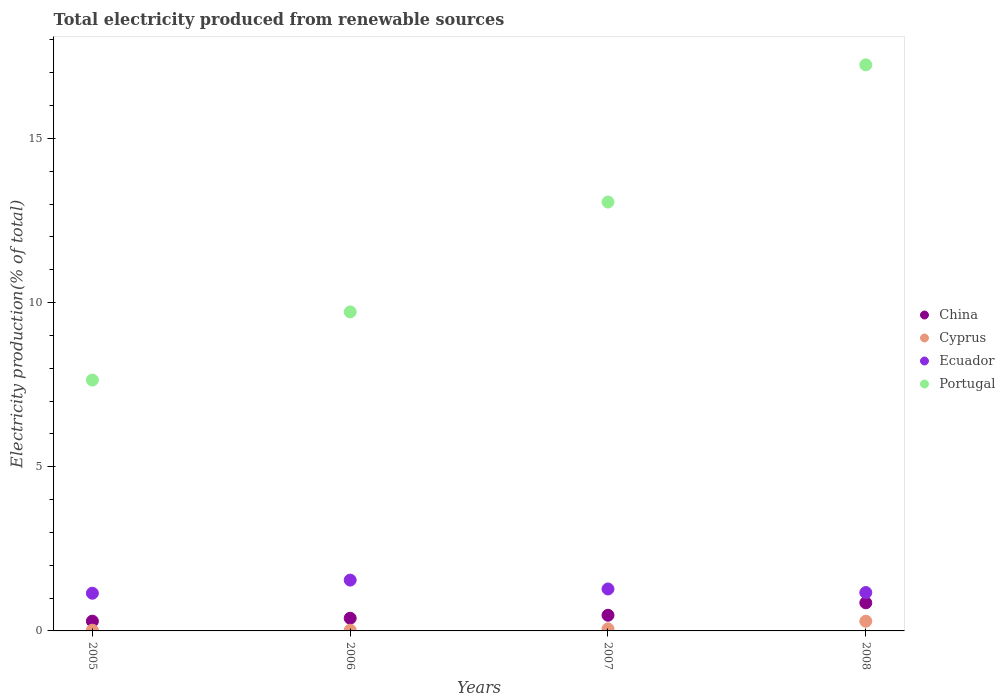How many different coloured dotlines are there?
Offer a terse response. 4. What is the total electricity produced in Cyprus in 2008?
Your response must be concise. 0.3. Across all years, what is the maximum total electricity produced in China?
Provide a succinct answer. 0.86. Across all years, what is the minimum total electricity produced in Ecuador?
Your response must be concise. 1.15. In which year was the total electricity produced in Portugal maximum?
Ensure brevity in your answer.  2008. What is the total total electricity produced in Ecuador in the graph?
Keep it short and to the point. 5.14. What is the difference between the total electricity produced in China in 2006 and that in 2008?
Keep it short and to the point. -0.47. What is the difference between the total electricity produced in China in 2006 and the total electricity produced in Cyprus in 2005?
Keep it short and to the point. 0.36. What is the average total electricity produced in Cyprus per year?
Provide a succinct answer. 0.1. In the year 2008, what is the difference between the total electricity produced in Ecuador and total electricity produced in Cyprus?
Provide a succinct answer. 0.87. In how many years, is the total electricity produced in China greater than 4 %?
Provide a short and direct response. 0. What is the ratio of the total electricity produced in Portugal in 2006 to that in 2008?
Offer a very short reply. 0.56. Is the total electricity produced in Ecuador in 2007 less than that in 2008?
Give a very brief answer. No. What is the difference between the highest and the second highest total electricity produced in Ecuador?
Ensure brevity in your answer.  0.27. What is the difference between the highest and the lowest total electricity produced in China?
Your answer should be compact. 0.56. In how many years, is the total electricity produced in Ecuador greater than the average total electricity produced in Ecuador taken over all years?
Make the answer very short. 1. Is the sum of the total electricity produced in China in 2005 and 2008 greater than the maximum total electricity produced in Ecuador across all years?
Your answer should be very brief. No. Is it the case that in every year, the sum of the total electricity produced in Portugal and total electricity produced in China  is greater than the total electricity produced in Ecuador?
Keep it short and to the point. Yes. Does the total electricity produced in Portugal monotonically increase over the years?
Your answer should be compact. Yes. Is the total electricity produced in Cyprus strictly less than the total electricity produced in Ecuador over the years?
Offer a terse response. Yes. How many years are there in the graph?
Provide a succinct answer. 4. Are the values on the major ticks of Y-axis written in scientific E-notation?
Your answer should be compact. No. How many legend labels are there?
Give a very brief answer. 4. How are the legend labels stacked?
Your response must be concise. Vertical. What is the title of the graph?
Provide a short and direct response. Total electricity produced from renewable sources. Does "Belgium" appear as one of the legend labels in the graph?
Keep it short and to the point. No. What is the label or title of the X-axis?
Your answer should be compact. Years. What is the Electricity production(% of total) of China in 2005?
Give a very brief answer. 0.3. What is the Electricity production(% of total) in Cyprus in 2005?
Your answer should be compact. 0.02. What is the Electricity production(% of total) in Ecuador in 2005?
Offer a very short reply. 1.15. What is the Electricity production(% of total) in Portugal in 2005?
Ensure brevity in your answer.  7.64. What is the Electricity production(% of total) in China in 2006?
Your response must be concise. 0.39. What is the Electricity production(% of total) of Cyprus in 2006?
Keep it short and to the point. 0.02. What is the Electricity production(% of total) in Ecuador in 2006?
Offer a very short reply. 1.55. What is the Electricity production(% of total) of Portugal in 2006?
Offer a terse response. 9.72. What is the Electricity production(% of total) in China in 2007?
Your answer should be compact. 0.48. What is the Electricity production(% of total) in Cyprus in 2007?
Keep it short and to the point. 0.06. What is the Electricity production(% of total) of Ecuador in 2007?
Your answer should be compact. 1.28. What is the Electricity production(% of total) in Portugal in 2007?
Make the answer very short. 13.06. What is the Electricity production(% of total) in China in 2008?
Make the answer very short. 0.86. What is the Electricity production(% of total) in Cyprus in 2008?
Your answer should be very brief. 0.3. What is the Electricity production(% of total) of Ecuador in 2008?
Your answer should be compact. 1.17. What is the Electricity production(% of total) of Portugal in 2008?
Your answer should be very brief. 17.24. Across all years, what is the maximum Electricity production(% of total) in China?
Your answer should be very brief. 0.86. Across all years, what is the maximum Electricity production(% of total) of Cyprus?
Give a very brief answer. 0.3. Across all years, what is the maximum Electricity production(% of total) in Ecuador?
Your answer should be compact. 1.55. Across all years, what is the maximum Electricity production(% of total) in Portugal?
Your response must be concise. 17.24. Across all years, what is the minimum Electricity production(% of total) of China?
Provide a short and direct response. 0.3. Across all years, what is the minimum Electricity production(% of total) in Cyprus?
Offer a terse response. 0.02. Across all years, what is the minimum Electricity production(% of total) in Ecuador?
Ensure brevity in your answer.  1.15. Across all years, what is the minimum Electricity production(% of total) in Portugal?
Provide a short and direct response. 7.64. What is the total Electricity production(% of total) in China in the graph?
Keep it short and to the point. 2.02. What is the total Electricity production(% of total) of Cyprus in the graph?
Offer a very short reply. 0.4. What is the total Electricity production(% of total) of Ecuador in the graph?
Your answer should be very brief. 5.14. What is the total Electricity production(% of total) in Portugal in the graph?
Your answer should be very brief. 47.66. What is the difference between the Electricity production(% of total) of China in 2005 and that in 2006?
Make the answer very short. -0.09. What is the difference between the Electricity production(% of total) in Cyprus in 2005 and that in 2006?
Ensure brevity in your answer.  0. What is the difference between the Electricity production(% of total) of Ecuador in 2005 and that in 2006?
Your answer should be very brief. -0.4. What is the difference between the Electricity production(% of total) in Portugal in 2005 and that in 2006?
Provide a short and direct response. -2.08. What is the difference between the Electricity production(% of total) of China in 2005 and that in 2007?
Provide a short and direct response. -0.18. What is the difference between the Electricity production(% of total) of Cyprus in 2005 and that in 2007?
Offer a terse response. -0.04. What is the difference between the Electricity production(% of total) of Ecuador in 2005 and that in 2007?
Make the answer very short. -0.13. What is the difference between the Electricity production(% of total) in Portugal in 2005 and that in 2007?
Your answer should be compact. -5.42. What is the difference between the Electricity production(% of total) of China in 2005 and that in 2008?
Offer a terse response. -0.56. What is the difference between the Electricity production(% of total) in Cyprus in 2005 and that in 2008?
Your answer should be compact. -0.27. What is the difference between the Electricity production(% of total) of Ecuador in 2005 and that in 2008?
Make the answer very short. -0.02. What is the difference between the Electricity production(% of total) of Portugal in 2005 and that in 2008?
Offer a terse response. -9.6. What is the difference between the Electricity production(% of total) in China in 2006 and that in 2007?
Keep it short and to the point. -0.09. What is the difference between the Electricity production(% of total) of Cyprus in 2006 and that in 2007?
Your answer should be very brief. -0.04. What is the difference between the Electricity production(% of total) of Ecuador in 2006 and that in 2007?
Your answer should be very brief. 0.27. What is the difference between the Electricity production(% of total) of Portugal in 2006 and that in 2007?
Offer a terse response. -3.35. What is the difference between the Electricity production(% of total) in China in 2006 and that in 2008?
Keep it short and to the point. -0.47. What is the difference between the Electricity production(% of total) in Cyprus in 2006 and that in 2008?
Offer a terse response. -0.27. What is the difference between the Electricity production(% of total) in Ecuador in 2006 and that in 2008?
Your response must be concise. 0.38. What is the difference between the Electricity production(% of total) of Portugal in 2006 and that in 2008?
Give a very brief answer. -7.53. What is the difference between the Electricity production(% of total) in China in 2007 and that in 2008?
Provide a short and direct response. -0.38. What is the difference between the Electricity production(% of total) in Cyprus in 2007 and that in 2008?
Your answer should be very brief. -0.23. What is the difference between the Electricity production(% of total) in Ecuador in 2007 and that in 2008?
Give a very brief answer. 0.11. What is the difference between the Electricity production(% of total) of Portugal in 2007 and that in 2008?
Your answer should be very brief. -4.18. What is the difference between the Electricity production(% of total) of China in 2005 and the Electricity production(% of total) of Cyprus in 2006?
Your answer should be compact. 0.28. What is the difference between the Electricity production(% of total) of China in 2005 and the Electricity production(% of total) of Ecuador in 2006?
Provide a short and direct response. -1.25. What is the difference between the Electricity production(% of total) of China in 2005 and the Electricity production(% of total) of Portugal in 2006?
Ensure brevity in your answer.  -9.42. What is the difference between the Electricity production(% of total) in Cyprus in 2005 and the Electricity production(% of total) in Ecuador in 2006?
Make the answer very short. -1.53. What is the difference between the Electricity production(% of total) in Cyprus in 2005 and the Electricity production(% of total) in Portugal in 2006?
Give a very brief answer. -9.69. What is the difference between the Electricity production(% of total) in Ecuador in 2005 and the Electricity production(% of total) in Portugal in 2006?
Provide a short and direct response. -8.57. What is the difference between the Electricity production(% of total) in China in 2005 and the Electricity production(% of total) in Cyprus in 2007?
Ensure brevity in your answer.  0.24. What is the difference between the Electricity production(% of total) in China in 2005 and the Electricity production(% of total) in Ecuador in 2007?
Your answer should be very brief. -0.98. What is the difference between the Electricity production(% of total) of China in 2005 and the Electricity production(% of total) of Portugal in 2007?
Make the answer very short. -12.77. What is the difference between the Electricity production(% of total) of Cyprus in 2005 and the Electricity production(% of total) of Ecuador in 2007?
Give a very brief answer. -1.25. What is the difference between the Electricity production(% of total) of Cyprus in 2005 and the Electricity production(% of total) of Portugal in 2007?
Your answer should be compact. -13.04. What is the difference between the Electricity production(% of total) of Ecuador in 2005 and the Electricity production(% of total) of Portugal in 2007?
Give a very brief answer. -11.91. What is the difference between the Electricity production(% of total) of China in 2005 and the Electricity production(% of total) of Cyprus in 2008?
Make the answer very short. 0. What is the difference between the Electricity production(% of total) of China in 2005 and the Electricity production(% of total) of Ecuador in 2008?
Offer a terse response. -0.87. What is the difference between the Electricity production(% of total) of China in 2005 and the Electricity production(% of total) of Portugal in 2008?
Your answer should be very brief. -16.94. What is the difference between the Electricity production(% of total) of Cyprus in 2005 and the Electricity production(% of total) of Ecuador in 2008?
Your answer should be compact. -1.15. What is the difference between the Electricity production(% of total) of Cyprus in 2005 and the Electricity production(% of total) of Portugal in 2008?
Keep it short and to the point. -17.22. What is the difference between the Electricity production(% of total) of Ecuador in 2005 and the Electricity production(% of total) of Portugal in 2008?
Ensure brevity in your answer.  -16.09. What is the difference between the Electricity production(% of total) of China in 2006 and the Electricity production(% of total) of Cyprus in 2007?
Your response must be concise. 0.33. What is the difference between the Electricity production(% of total) in China in 2006 and the Electricity production(% of total) in Ecuador in 2007?
Your response must be concise. -0.89. What is the difference between the Electricity production(% of total) of China in 2006 and the Electricity production(% of total) of Portugal in 2007?
Provide a succinct answer. -12.68. What is the difference between the Electricity production(% of total) of Cyprus in 2006 and the Electricity production(% of total) of Ecuador in 2007?
Provide a succinct answer. -1.26. What is the difference between the Electricity production(% of total) in Cyprus in 2006 and the Electricity production(% of total) in Portugal in 2007?
Your answer should be compact. -13.04. What is the difference between the Electricity production(% of total) in Ecuador in 2006 and the Electricity production(% of total) in Portugal in 2007?
Make the answer very short. -11.52. What is the difference between the Electricity production(% of total) in China in 2006 and the Electricity production(% of total) in Cyprus in 2008?
Your answer should be very brief. 0.09. What is the difference between the Electricity production(% of total) in China in 2006 and the Electricity production(% of total) in Ecuador in 2008?
Offer a terse response. -0.78. What is the difference between the Electricity production(% of total) of China in 2006 and the Electricity production(% of total) of Portugal in 2008?
Your answer should be very brief. -16.86. What is the difference between the Electricity production(% of total) of Cyprus in 2006 and the Electricity production(% of total) of Ecuador in 2008?
Keep it short and to the point. -1.15. What is the difference between the Electricity production(% of total) in Cyprus in 2006 and the Electricity production(% of total) in Portugal in 2008?
Your answer should be very brief. -17.22. What is the difference between the Electricity production(% of total) in Ecuador in 2006 and the Electricity production(% of total) in Portugal in 2008?
Offer a terse response. -15.69. What is the difference between the Electricity production(% of total) of China in 2007 and the Electricity production(% of total) of Cyprus in 2008?
Your answer should be very brief. 0.18. What is the difference between the Electricity production(% of total) in China in 2007 and the Electricity production(% of total) in Ecuador in 2008?
Provide a succinct answer. -0.69. What is the difference between the Electricity production(% of total) of China in 2007 and the Electricity production(% of total) of Portugal in 2008?
Ensure brevity in your answer.  -16.76. What is the difference between the Electricity production(% of total) in Cyprus in 2007 and the Electricity production(% of total) in Ecuador in 2008?
Your answer should be compact. -1.11. What is the difference between the Electricity production(% of total) in Cyprus in 2007 and the Electricity production(% of total) in Portugal in 2008?
Keep it short and to the point. -17.18. What is the difference between the Electricity production(% of total) in Ecuador in 2007 and the Electricity production(% of total) in Portugal in 2008?
Offer a very short reply. -15.96. What is the average Electricity production(% of total) in China per year?
Provide a succinct answer. 0.5. What is the average Electricity production(% of total) of Cyprus per year?
Make the answer very short. 0.1. What is the average Electricity production(% of total) in Ecuador per year?
Ensure brevity in your answer.  1.29. What is the average Electricity production(% of total) of Portugal per year?
Offer a terse response. 11.92. In the year 2005, what is the difference between the Electricity production(% of total) of China and Electricity production(% of total) of Cyprus?
Offer a terse response. 0.27. In the year 2005, what is the difference between the Electricity production(% of total) of China and Electricity production(% of total) of Ecuador?
Offer a terse response. -0.85. In the year 2005, what is the difference between the Electricity production(% of total) in China and Electricity production(% of total) in Portugal?
Offer a very short reply. -7.34. In the year 2005, what is the difference between the Electricity production(% of total) in Cyprus and Electricity production(% of total) in Ecuador?
Your response must be concise. -1.13. In the year 2005, what is the difference between the Electricity production(% of total) of Cyprus and Electricity production(% of total) of Portugal?
Make the answer very short. -7.62. In the year 2005, what is the difference between the Electricity production(% of total) of Ecuador and Electricity production(% of total) of Portugal?
Your answer should be compact. -6.49. In the year 2006, what is the difference between the Electricity production(% of total) of China and Electricity production(% of total) of Cyprus?
Keep it short and to the point. 0.37. In the year 2006, what is the difference between the Electricity production(% of total) in China and Electricity production(% of total) in Ecuador?
Your response must be concise. -1.16. In the year 2006, what is the difference between the Electricity production(% of total) in China and Electricity production(% of total) in Portugal?
Ensure brevity in your answer.  -9.33. In the year 2006, what is the difference between the Electricity production(% of total) in Cyprus and Electricity production(% of total) in Ecuador?
Your answer should be very brief. -1.53. In the year 2006, what is the difference between the Electricity production(% of total) of Cyprus and Electricity production(% of total) of Portugal?
Give a very brief answer. -9.7. In the year 2006, what is the difference between the Electricity production(% of total) in Ecuador and Electricity production(% of total) in Portugal?
Your response must be concise. -8.17. In the year 2007, what is the difference between the Electricity production(% of total) in China and Electricity production(% of total) in Cyprus?
Your answer should be compact. 0.42. In the year 2007, what is the difference between the Electricity production(% of total) of China and Electricity production(% of total) of Ecuador?
Provide a succinct answer. -0.8. In the year 2007, what is the difference between the Electricity production(% of total) in China and Electricity production(% of total) in Portugal?
Give a very brief answer. -12.59. In the year 2007, what is the difference between the Electricity production(% of total) in Cyprus and Electricity production(% of total) in Ecuador?
Provide a short and direct response. -1.22. In the year 2007, what is the difference between the Electricity production(% of total) of Cyprus and Electricity production(% of total) of Portugal?
Your answer should be very brief. -13. In the year 2007, what is the difference between the Electricity production(% of total) of Ecuador and Electricity production(% of total) of Portugal?
Your response must be concise. -11.79. In the year 2008, what is the difference between the Electricity production(% of total) in China and Electricity production(% of total) in Cyprus?
Offer a terse response. 0.56. In the year 2008, what is the difference between the Electricity production(% of total) in China and Electricity production(% of total) in Ecuador?
Your answer should be compact. -0.31. In the year 2008, what is the difference between the Electricity production(% of total) of China and Electricity production(% of total) of Portugal?
Make the answer very short. -16.39. In the year 2008, what is the difference between the Electricity production(% of total) in Cyprus and Electricity production(% of total) in Ecuador?
Offer a terse response. -0.87. In the year 2008, what is the difference between the Electricity production(% of total) in Cyprus and Electricity production(% of total) in Portugal?
Give a very brief answer. -16.95. In the year 2008, what is the difference between the Electricity production(% of total) in Ecuador and Electricity production(% of total) in Portugal?
Offer a very short reply. -16.07. What is the ratio of the Electricity production(% of total) in China in 2005 to that in 2006?
Make the answer very short. 0.77. What is the ratio of the Electricity production(% of total) of Cyprus in 2005 to that in 2006?
Offer a very short reply. 1.06. What is the ratio of the Electricity production(% of total) in Ecuador in 2005 to that in 2006?
Provide a short and direct response. 0.74. What is the ratio of the Electricity production(% of total) in Portugal in 2005 to that in 2006?
Keep it short and to the point. 0.79. What is the ratio of the Electricity production(% of total) in China in 2005 to that in 2007?
Offer a terse response. 0.62. What is the ratio of the Electricity production(% of total) in Cyprus in 2005 to that in 2007?
Ensure brevity in your answer.  0.37. What is the ratio of the Electricity production(% of total) of Ecuador in 2005 to that in 2007?
Your answer should be very brief. 0.9. What is the ratio of the Electricity production(% of total) of Portugal in 2005 to that in 2007?
Give a very brief answer. 0.58. What is the ratio of the Electricity production(% of total) in China in 2005 to that in 2008?
Provide a succinct answer. 0.35. What is the ratio of the Electricity production(% of total) in Cyprus in 2005 to that in 2008?
Provide a short and direct response. 0.08. What is the ratio of the Electricity production(% of total) of Ecuador in 2005 to that in 2008?
Offer a terse response. 0.98. What is the ratio of the Electricity production(% of total) of Portugal in 2005 to that in 2008?
Keep it short and to the point. 0.44. What is the ratio of the Electricity production(% of total) in China in 2006 to that in 2007?
Give a very brief answer. 0.81. What is the ratio of the Electricity production(% of total) of Cyprus in 2006 to that in 2007?
Give a very brief answer. 0.35. What is the ratio of the Electricity production(% of total) in Ecuador in 2006 to that in 2007?
Your response must be concise. 1.21. What is the ratio of the Electricity production(% of total) in Portugal in 2006 to that in 2007?
Your answer should be very brief. 0.74. What is the ratio of the Electricity production(% of total) of China in 2006 to that in 2008?
Offer a terse response. 0.45. What is the ratio of the Electricity production(% of total) of Cyprus in 2006 to that in 2008?
Make the answer very short. 0.07. What is the ratio of the Electricity production(% of total) in Ecuador in 2006 to that in 2008?
Your answer should be compact. 1.32. What is the ratio of the Electricity production(% of total) of Portugal in 2006 to that in 2008?
Give a very brief answer. 0.56. What is the ratio of the Electricity production(% of total) of China in 2007 to that in 2008?
Your answer should be compact. 0.56. What is the ratio of the Electricity production(% of total) in Cyprus in 2007 to that in 2008?
Offer a terse response. 0.21. What is the ratio of the Electricity production(% of total) of Ecuador in 2007 to that in 2008?
Your answer should be compact. 1.09. What is the ratio of the Electricity production(% of total) in Portugal in 2007 to that in 2008?
Your answer should be compact. 0.76. What is the difference between the highest and the second highest Electricity production(% of total) in China?
Give a very brief answer. 0.38. What is the difference between the highest and the second highest Electricity production(% of total) of Cyprus?
Make the answer very short. 0.23. What is the difference between the highest and the second highest Electricity production(% of total) of Ecuador?
Your answer should be very brief. 0.27. What is the difference between the highest and the second highest Electricity production(% of total) in Portugal?
Your answer should be very brief. 4.18. What is the difference between the highest and the lowest Electricity production(% of total) of China?
Offer a very short reply. 0.56. What is the difference between the highest and the lowest Electricity production(% of total) of Cyprus?
Make the answer very short. 0.27. What is the difference between the highest and the lowest Electricity production(% of total) of Ecuador?
Your answer should be very brief. 0.4. What is the difference between the highest and the lowest Electricity production(% of total) of Portugal?
Your response must be concise. 9.6. 